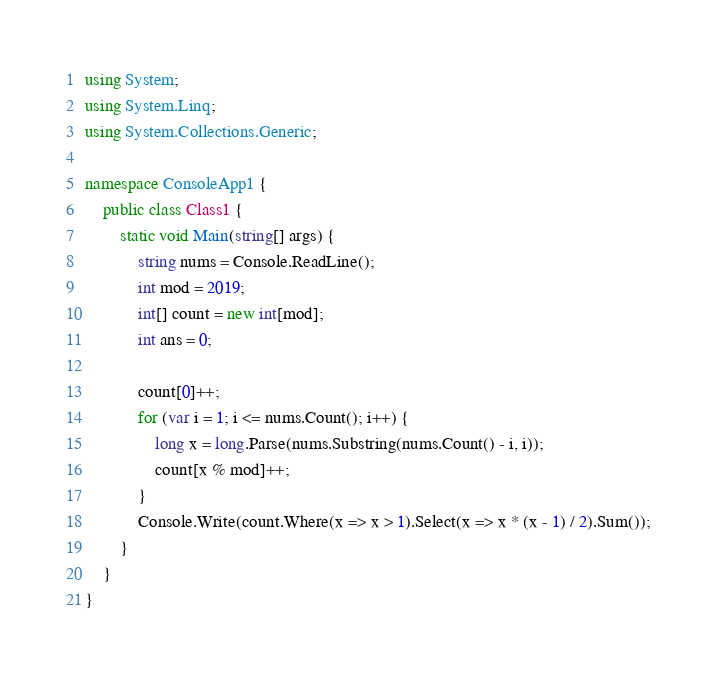Convert code to text. <code><loc_0><loc_0><loc_500><loc_500><_C#_>using System;
using System.Linq;
using System.Collections.Generic;

namespace ConsoleApp1 {
    public class Class1 {
        static void Main(string[] args) {
            string nums = Console.ReadLine();
            int mod = 2019;
            int[] count = new int[mod];
            int ans = 0;

            count[0]++;
            for (var i = 1; i <= nums.Count(); i++) {
                long x = long.Parse(nums.Substring(nums.Count() - i, i));
                count[x % mod]++;
            }
            Console.Write(count.Where(x => x > 1).Select(x => x * (x - 1) / 2).Sum());
        }
    }
}</code> 